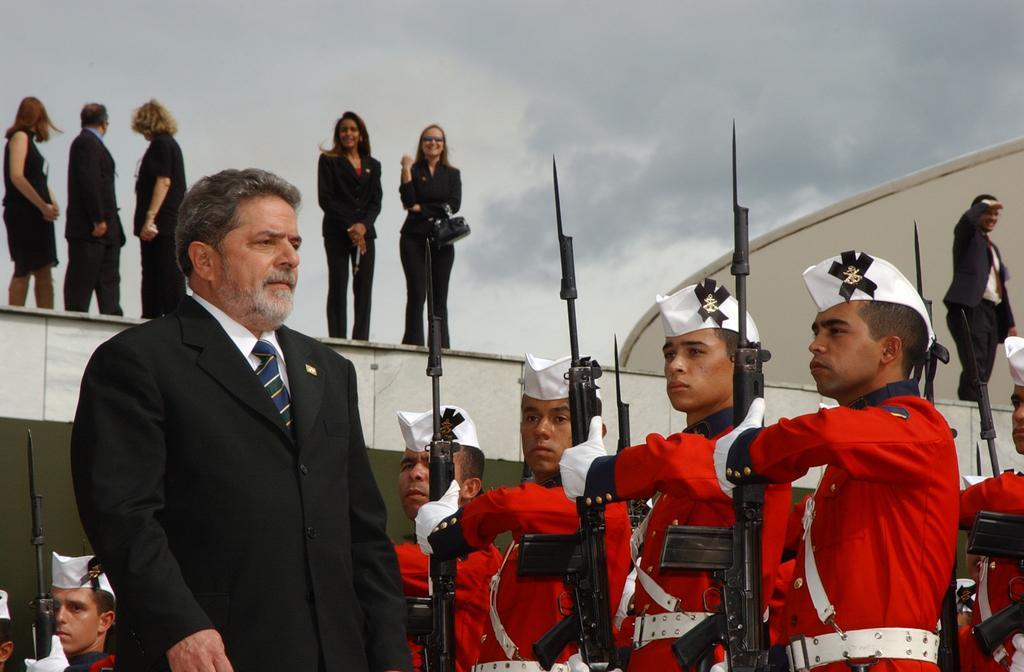Can you describe this image briefly? On the left a man is standing. In the background there are few persons wore same uniform and holding gun in their hands and there are few persons standing on a platform and we can see clouds in the sky. 